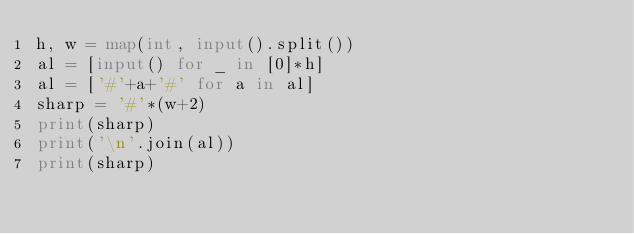<code> <loc_0><loc_0><loc_500><loc_500><_Python_>h, w = map(int, input().split())
al = [input() for _ in [0]*h]
al = ['#'+a+'#' for a in al]
sharp = '#'*(w+2)
print(sharp)
print('\n'.join(al))
print(sharp)</code> 